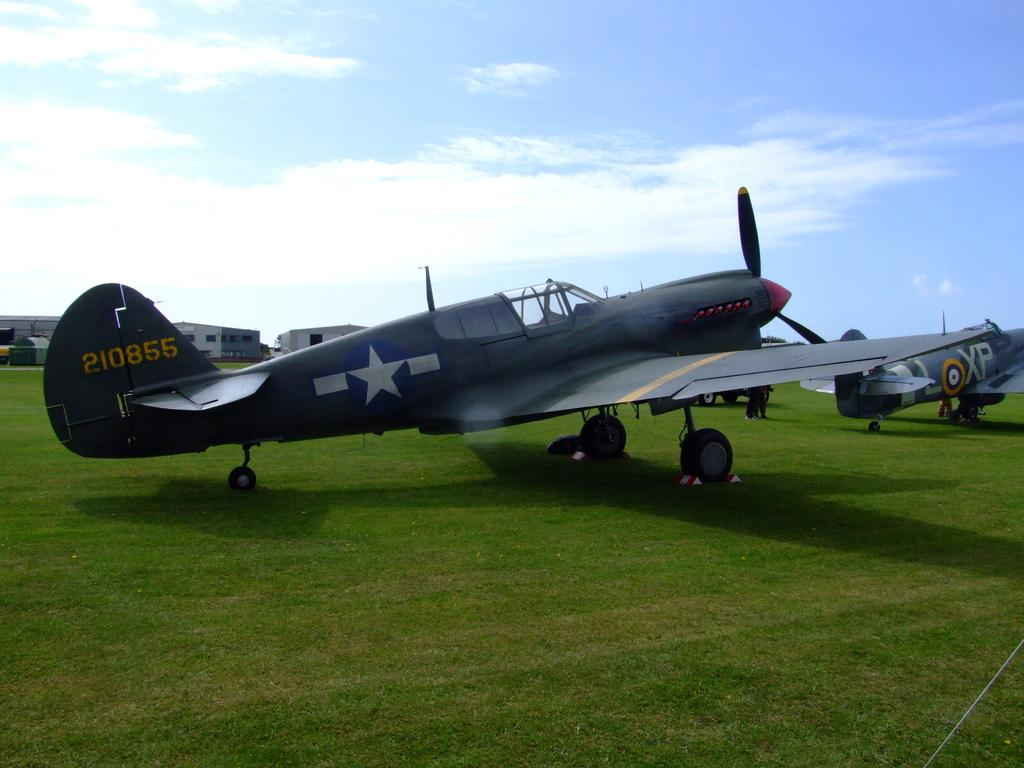<image>
Render a clear and concise summary of the photo. An old propellor plane with 210855 on the tail sits on a grass airfield 